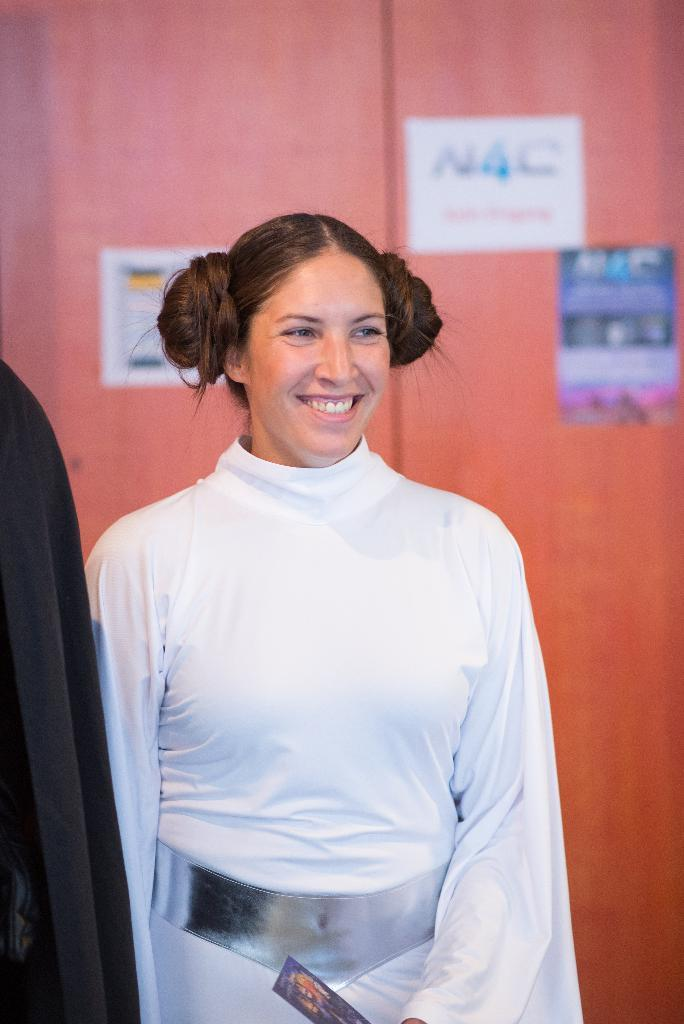Who is present in the image? There is a woman in the image. What is the woman holding in her hand? The woman is holding a photo in her hand. What is the woman's facial expression in the image? The woman is standing and smiling in the image. What can be seen beside the woman? There is a black cloth beside the woman. What is visible in the background of the image? There are posters on the wall in the background of the image. What type of nerve can be seen in the image? There is no nerve present in the image; it features a woman holding a photo and standing beside a black cloth. 